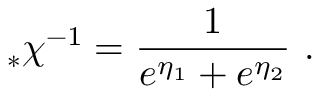Convert formula to latex. <formula><loc_0><loc_0><loc_500><loc_500>_ { * } \chi ^ { - 1 } = \frac { 1 } { e ^ { \eta _ { 1 } } + e ^ { \eta _ { 2 } } } \, .</formula> 